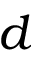Convert formula to latex. <formula><loc_0><loc_0><loc_500><loc_500>d</formula> 